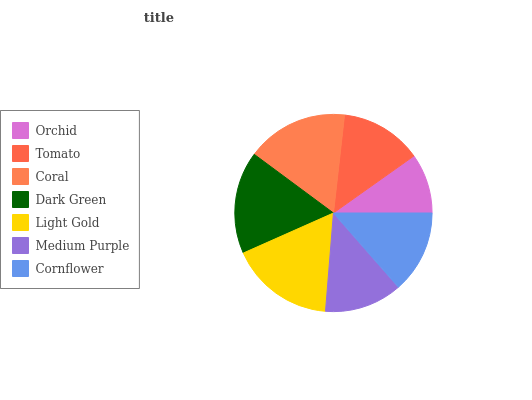Is Orchid the minimum?
Answer yes or no. Yes. Is Light Gold the maximum?
Answer yes or no. Yes. Is Tomato the minimum?
Answer yes or no. No. Is Tomato the maximum?
Answer yes or no. No. Is Tomato greater than Orchid?
Answer yes or no. Yes. Is Orchid less than Tomato?
Answer yes or no. Yes. Is Orchid greater than Tomato?
Answer yes or no. No. Is Tomato less than Orchid?
Answer yes or no. No. Is Cornflower the high median?
Answer yes or no. Yes. Is Cornflower the low median?
Answer yes or no. Yes. Is Tomato the high median?
Answer yes or no. No. Is Dark Green the low median?
Answer yes or no. No. 